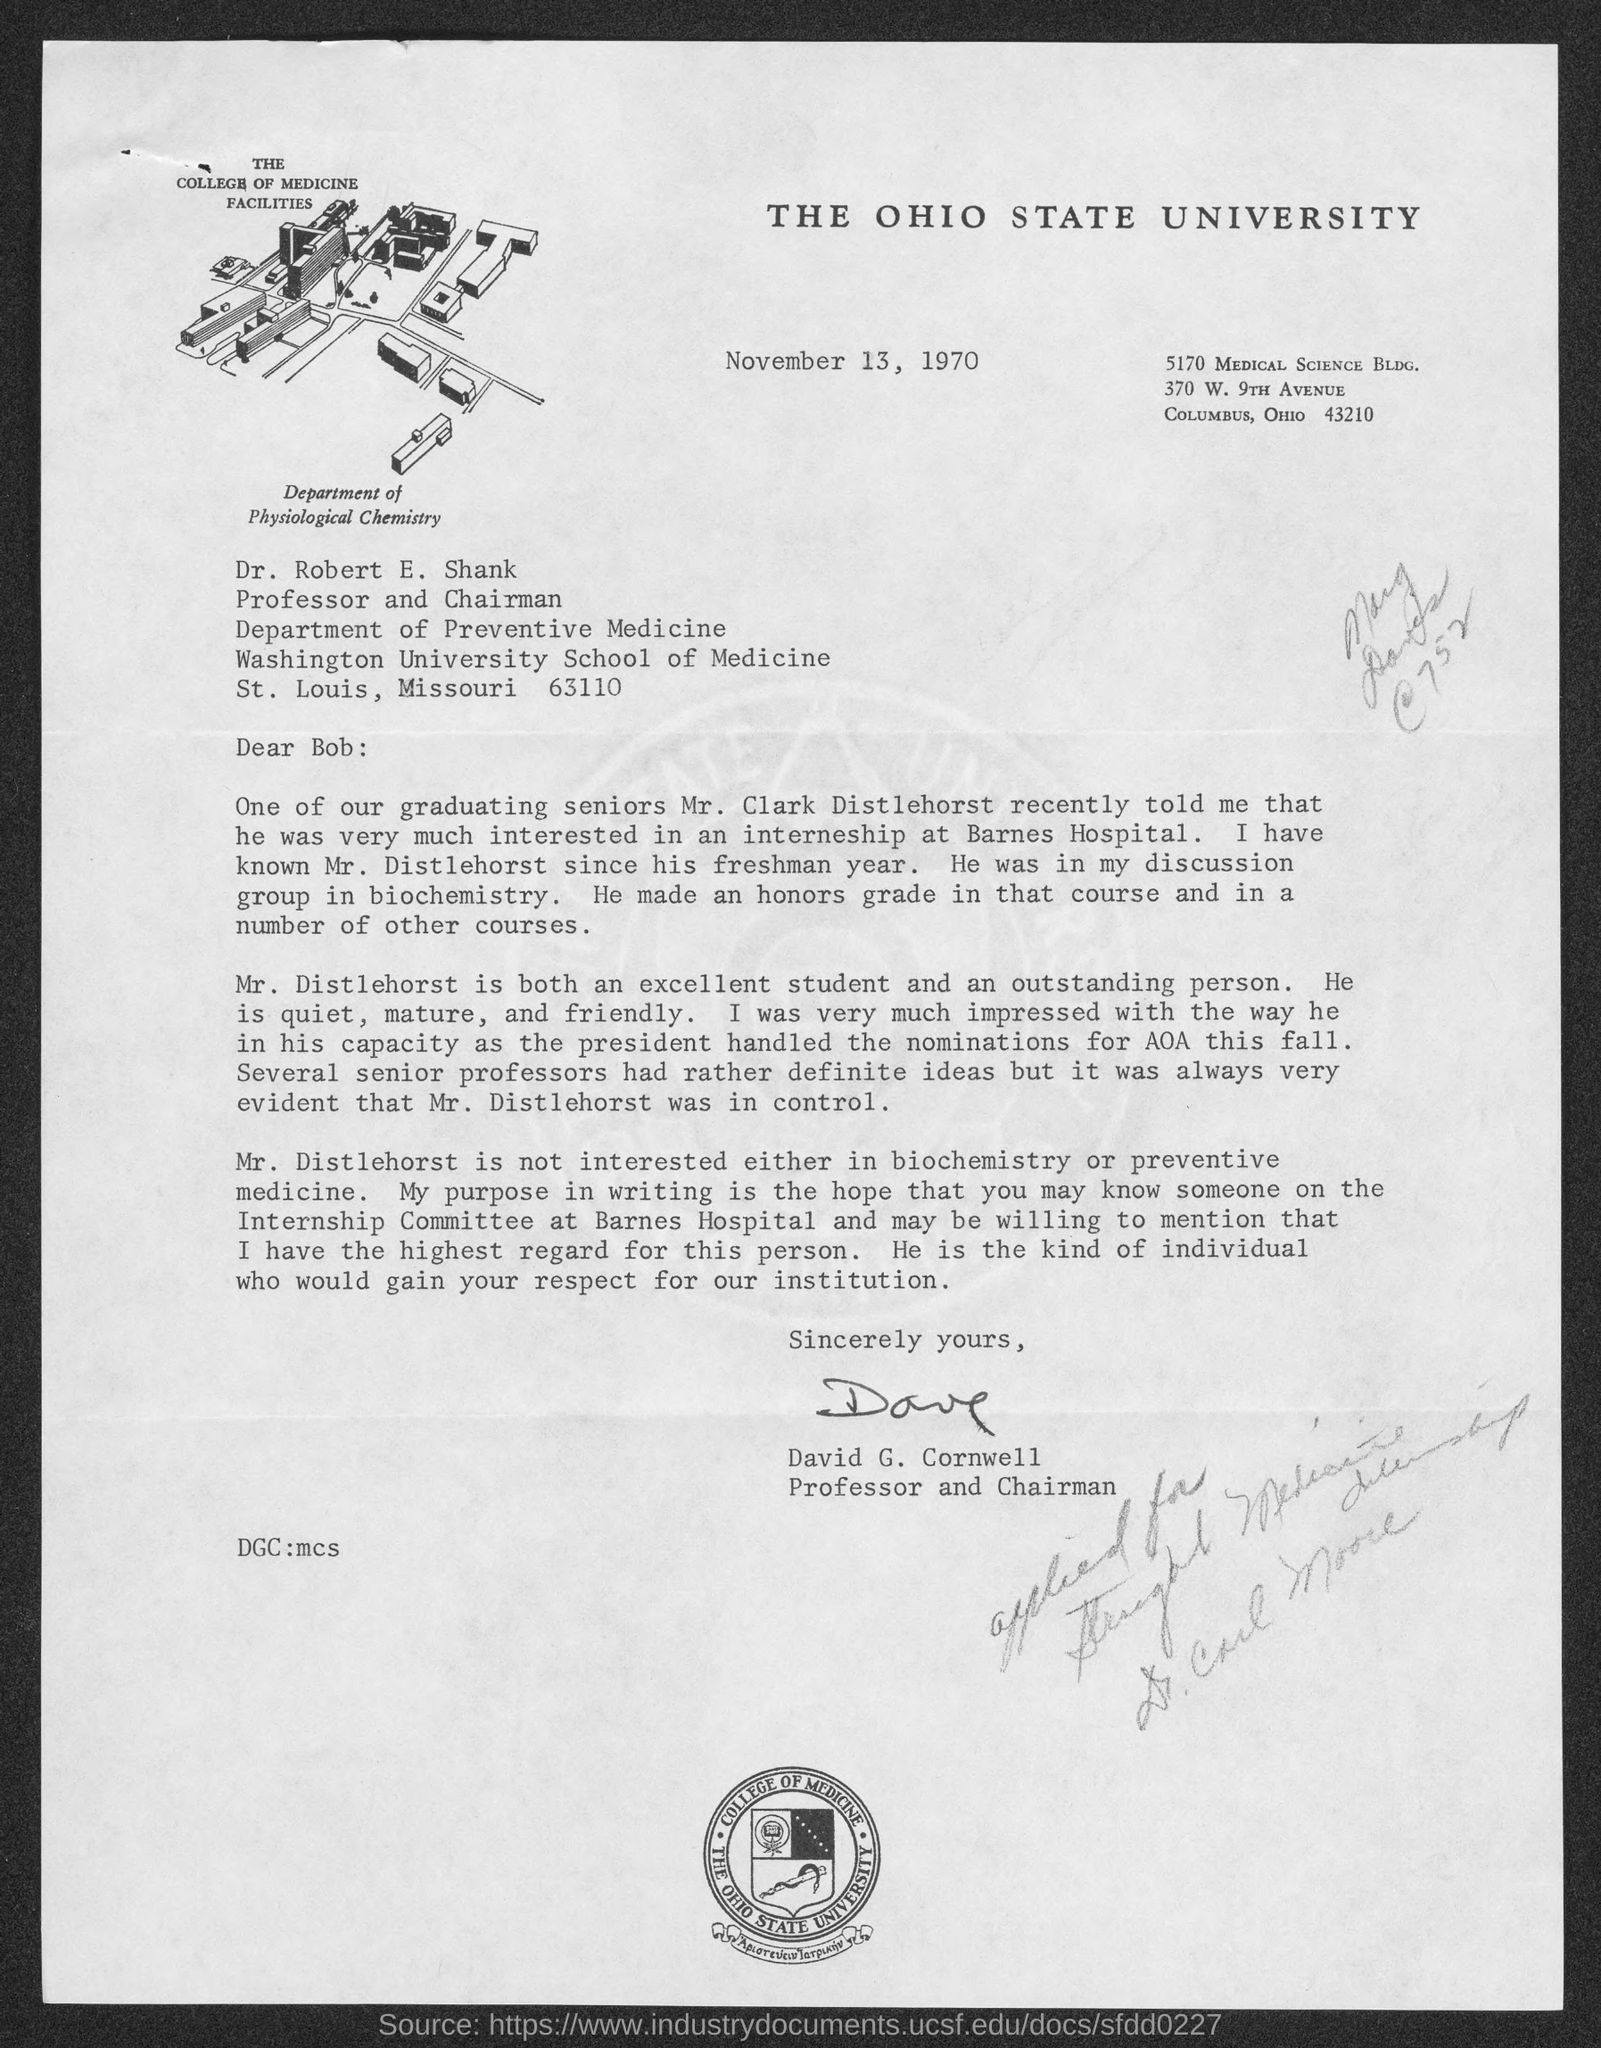What is the title of the document ?
Your answer should be very brief. THE  OHIO STATE UNIVERSITY. What is the date mentioned in the document ?
Keep it short and to the point. November 13, 1970. 